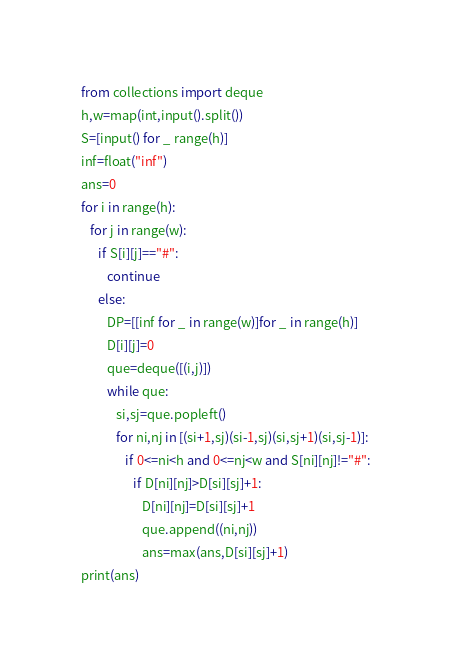Convert code to text. <code><loc_0><loc_0><loc_500><loc_500><_Python_>from collections import deque
h,w=map(int,input().split())
S=[input() for _ range(h)]
inf=float("inf")
ans=0
for i in range(h):
   for j in range(w):
      if S[i][j]=="#":
         continue
      else:
         DP=[[inf for _ in range(w)]for _ in range(h)]
         D[i][j]=0
         que=deque([(i,j)])
         while que:
            si,sj=que.popleft()
            for ni,nj in [(si+1,sj)(si-1,sj)(si,sj+1)(si,sj-1)]:
               if 0<=ni<h and 0<=nj<w and S[ni][nj]!="#":
                  if D[ni][nj]>D[si][sj]+1:
                     D[ni][nj]=D[si][sj]+1
                     que.append((ni,nj))
                     ans=max(ans,D[si][sj]+1)
print(ans)</code> 